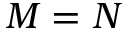Convert formula to latex. <formula><loc_0><loc_0><loc_500><loc_500>M = N</formula> 